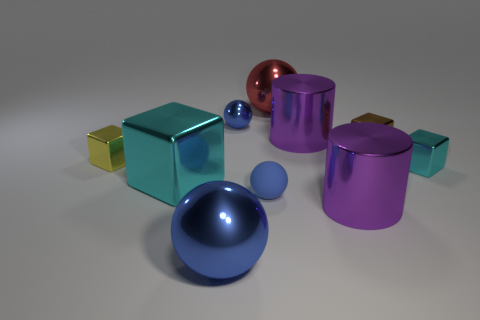There is a matte object; does it have the same color as the thing that is to the right of the brown cube?
Provide a succinct answer. No. The rubber thing is what color?
Your response must be concise. Blue. Does the big shiny cylinder in front of the big cyan metal object have the same color as the large metallic block?
Offer a terse response. No. What is the material of the big thing that is the same color as the tiny shiny ball?
Your response must be concise. Metal. What number of other large spheres have the same color as the rubber ball?
Offer a very short reply. 1. There is another shiny cube that is the same color as the big metal block; what is its size?
Offer a very short reply. Small. Are there any purple metallic objects of the same size as the red shiny object?
Give a very brief answer. Yes. There is a small cyan metallic object; is it the same shape as the big purple metal thing behind the big cyan metal object?
Your response must be concise. No. Do the purple thing that is behind the rubber ball and the cyan block that is to the right of the tiny blue matte thing have the same size?
Your response must be concise. No. What number of other objects are the same shape as the yellow shiny thing?
Ensure brevity in your answer.  3. 